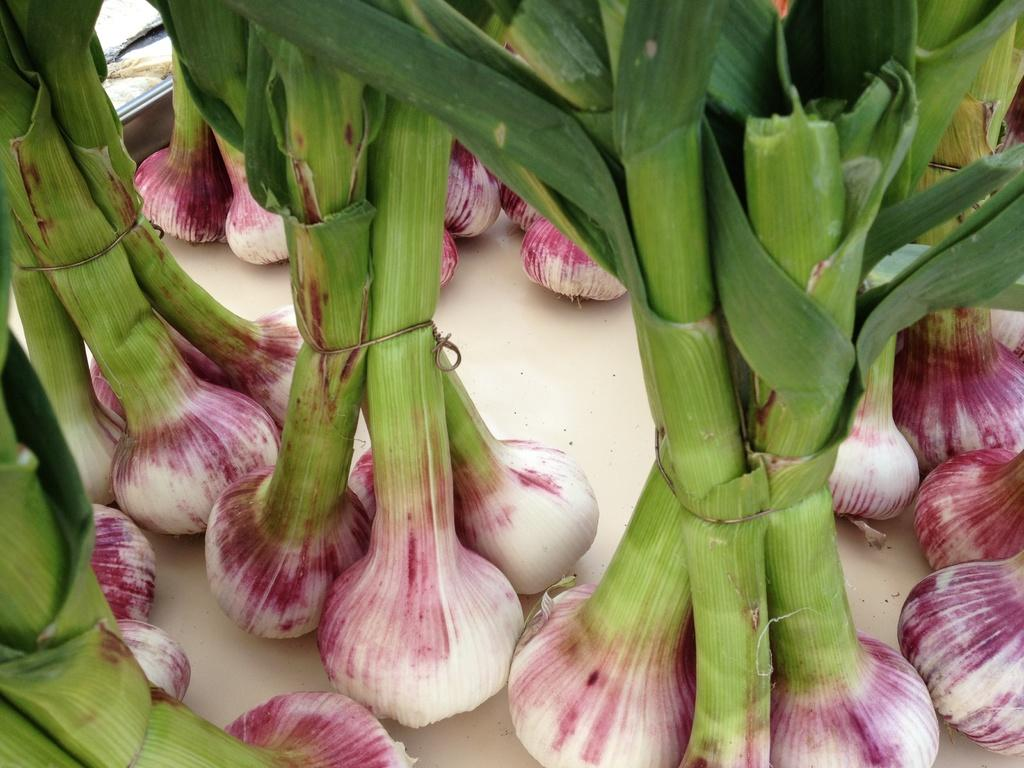What is the main color of the object in the image? The main color of the object in the image is cream. What is placed on the cream-colored object? Onions with leaves are present on the cream-colored object. Can you describe the unspecified objects at the top left side of the image? Unfortunately, the facts provided do not give any details about the unspecified objects at the top left side of the image. How many geese are present in the image? There are no geese present in the image. What are the girls doing in the image? There are no girls present in the image. 